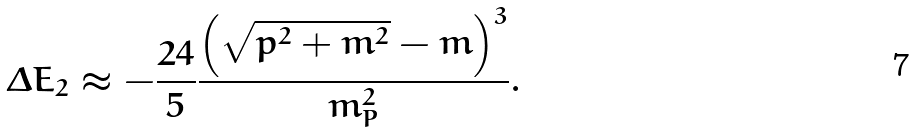<formula> <loc_0><loc_0><loc_500><loc_500>\Delta E _ { 2 } \approx - \frac { 2 4 } { 5 } \frac { \left ( \sqrt { p ^ { 2 } + m ^ { 2 } } - m \right ) ^ { 3 } } { m _ { P } ^ { 2 } } .</formula> 